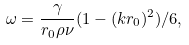Convert formula to latex. <formula><loc_0><loc_0><loc_500><loc_500>\omega = \frac { \gamma } { r _ { 0 } \rho \nu } ( 1 - ( k r _ { 0 } ) ^ { 2 } ) / 6 ,</formula> 